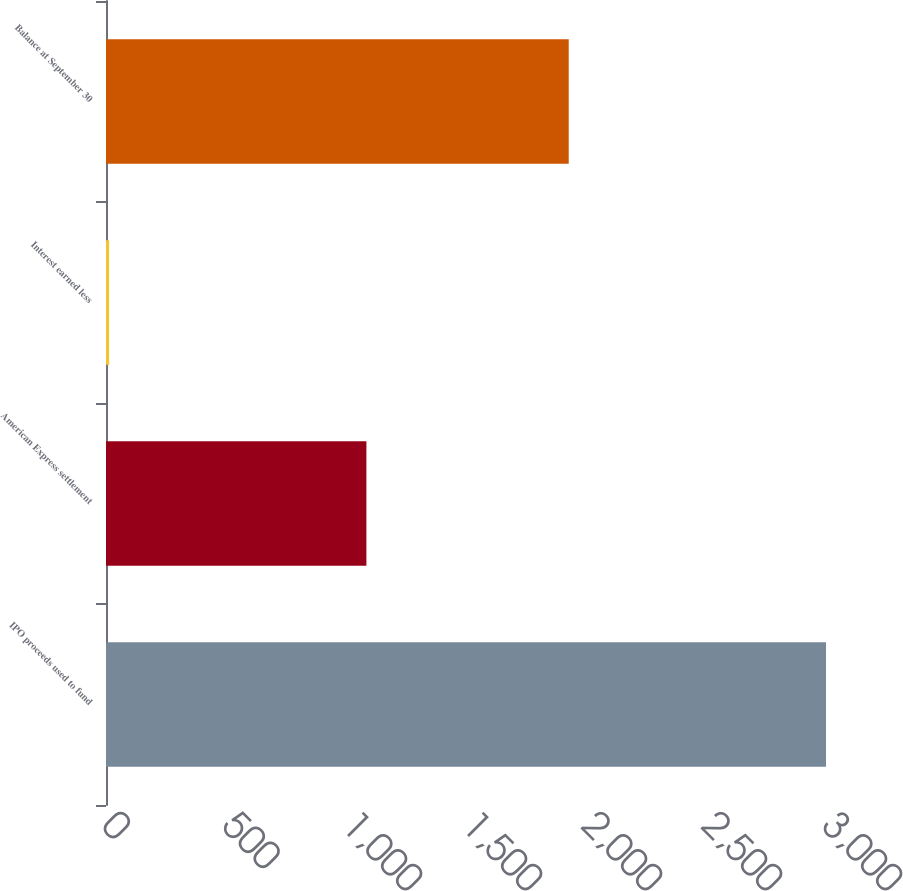Convert chart to OTSL. <chart><loc_0><loc_0><loc_500><loc_500><bar_chart><fcel>IPO proceeds used to fund<fcel>American Express settlement<fcel>Interest earned less<fcel>Balance at September 30<nl><fcel>3000<fcel>1085<fcel>13<fcel>1928<nl></chart> 